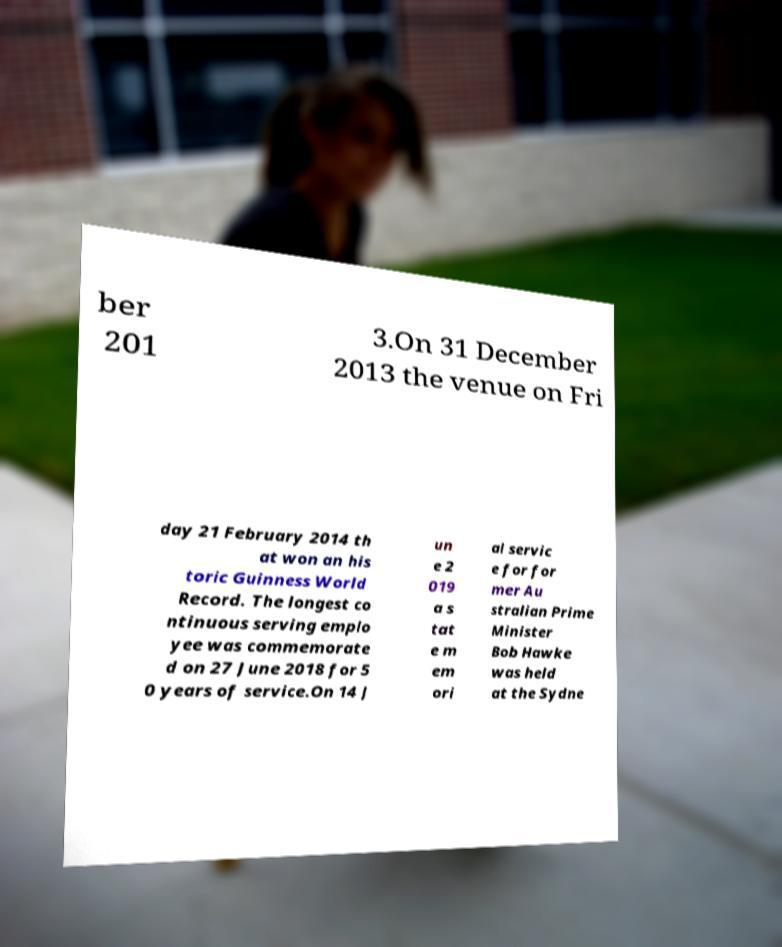For documentation purposes, I need the text within this image transcribed. Could you provide that? ber 201 3.On 31 December 2013 the venue on Fri day 21 February 2014 th at won an his toric Guinness World Record. The longest co ntinuous serving emplo yee was commemorate d on 27 June 2018 for 5 0 years of service.On 14 J un e 2 019 a s tat e m em ori al servic e for for mer Au stralian Prime Minister Bob Hawke was held at the Sydne 